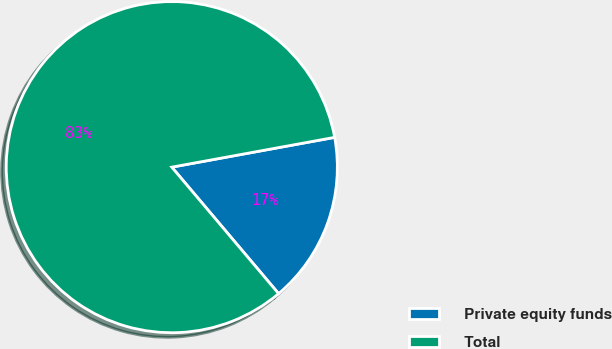<chart> <loc_0><loc_0><loc_500><loc_500><pie_chart><fcel>Private equity funds<fcel>Total<nl><fcel>16.72%<fcel>83.28%<nl></chart> 